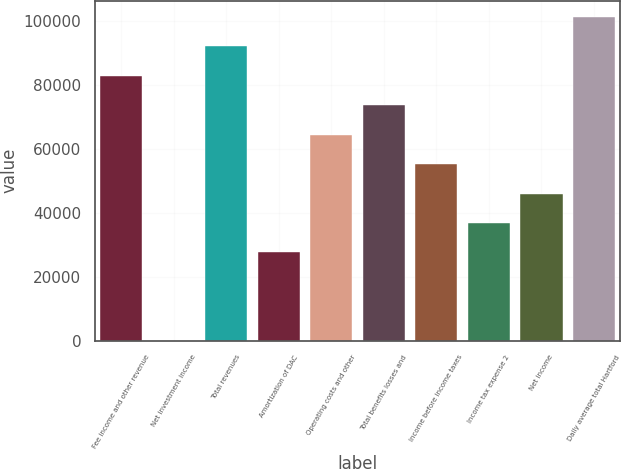Convert chart. <chart><loc_0><loc_0><loc_500><loc_500><bar_chart><fcel>Fee income and other revenue<fcel>Net investment income<fcel>Total revenues<fcel>Amortization of DAC<fcel>Operating costs and other<fcel>Total benefits losses and<fcel>Income before income taxes<fcel>Income tax expense 2<fcel>Net income<fcel>Daily average total Hartford<nl><fcel>82837.9<fcel>1<fcel>92042<fcel>27613.3<fcel>64429.7<fcel>73633.8<fcel>55225.6<fcel>36817.4<fcel>46021.5<fcel>101246<nl></chart> 